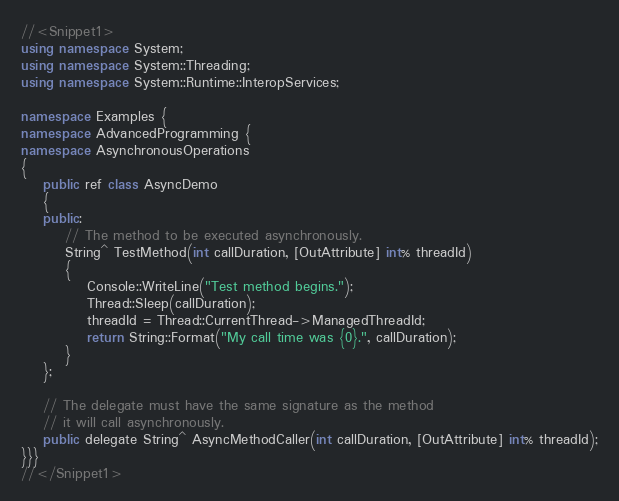<code> <loc_0><loc_0><loc_500><loc_500><_C++_>//<Snippet1>
using namespace System;
using namespace System::Threading;
using namespace System::Runtime::InteropServices; 

namespace Examples {
namespace AdvancedProgramming {
namespace AsynchronousOperations
{
    public ref class AsyncDemo 
    {
    public:
        // The method to be executed asynchronously.
        String^ TestMethod(int callDuration, [OutAttribute] int% threadId) 
        {
            Console::WriteLine("Test method begins.");
            Thread::Sleep(callDuration);
            threadId = Thread::CurrentThread->ManagedThreadId;
            return String::Format("My call time was {0}.", callDuration);
        }
    };

    // The delegate must have the same signature as the method
    // it will call asynchronously.
    public delegate String^ AsyncMethodCaller(int callDuration, [OutAttribute] int% threadId);
}}}
//</Snippet1>
</code> 